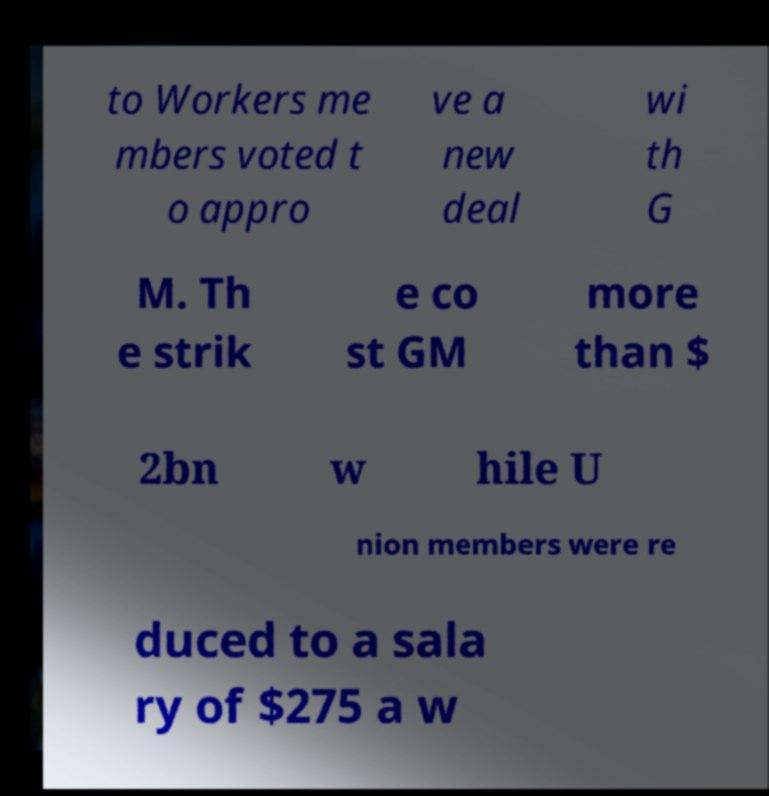Can you read and provide the text displayed in the image?This photo seems to have some interesting text. Can you extract and type it out for me? to Workers me mbers voted t o appro ve a new deal wi th G M. Th e strik e co st GM more than $ 2bn w hile U nion members were re duced to a sala ry of $275 a w 